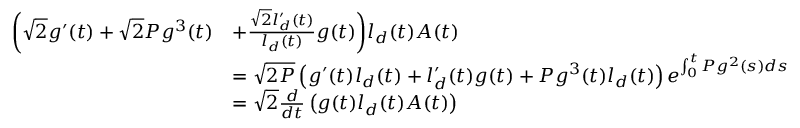<formula> <loc_0><loc_0><loc_500><loc_500>\begin{array} { r l } { \left ( \sqrt { 2 } g ^ { \prime } ( t ) + \sqrt { 2 } P g ^ { 3 } ( t ) } & { + \frac { \sqrt { 2 } l _ { d } ^ { \prime } ( t ) } { l _ { d } ( t ) } g ( t ) \right ) l _ { d } ( t ) A ( t ) } \\ & { = \sqrt { 2 P } \left ( g ^ { \prime } ( t ) l _ { d } ( t ) + l _ { d } ^ { \prime } ( t ) g ( t ) + P g ^ { 3 } ( t ) l _ { d } ( t ) \right ) e ^ { \int _ { 0 } ^ { t } P g ^ { 2 } ( s ) d s } } \\ & { = \sqrt { 2 } \frac { d } { d t } \left ( g ( t ) l _ { d } ( t ) A ( t ) \right ) } \end{array}</formula> 